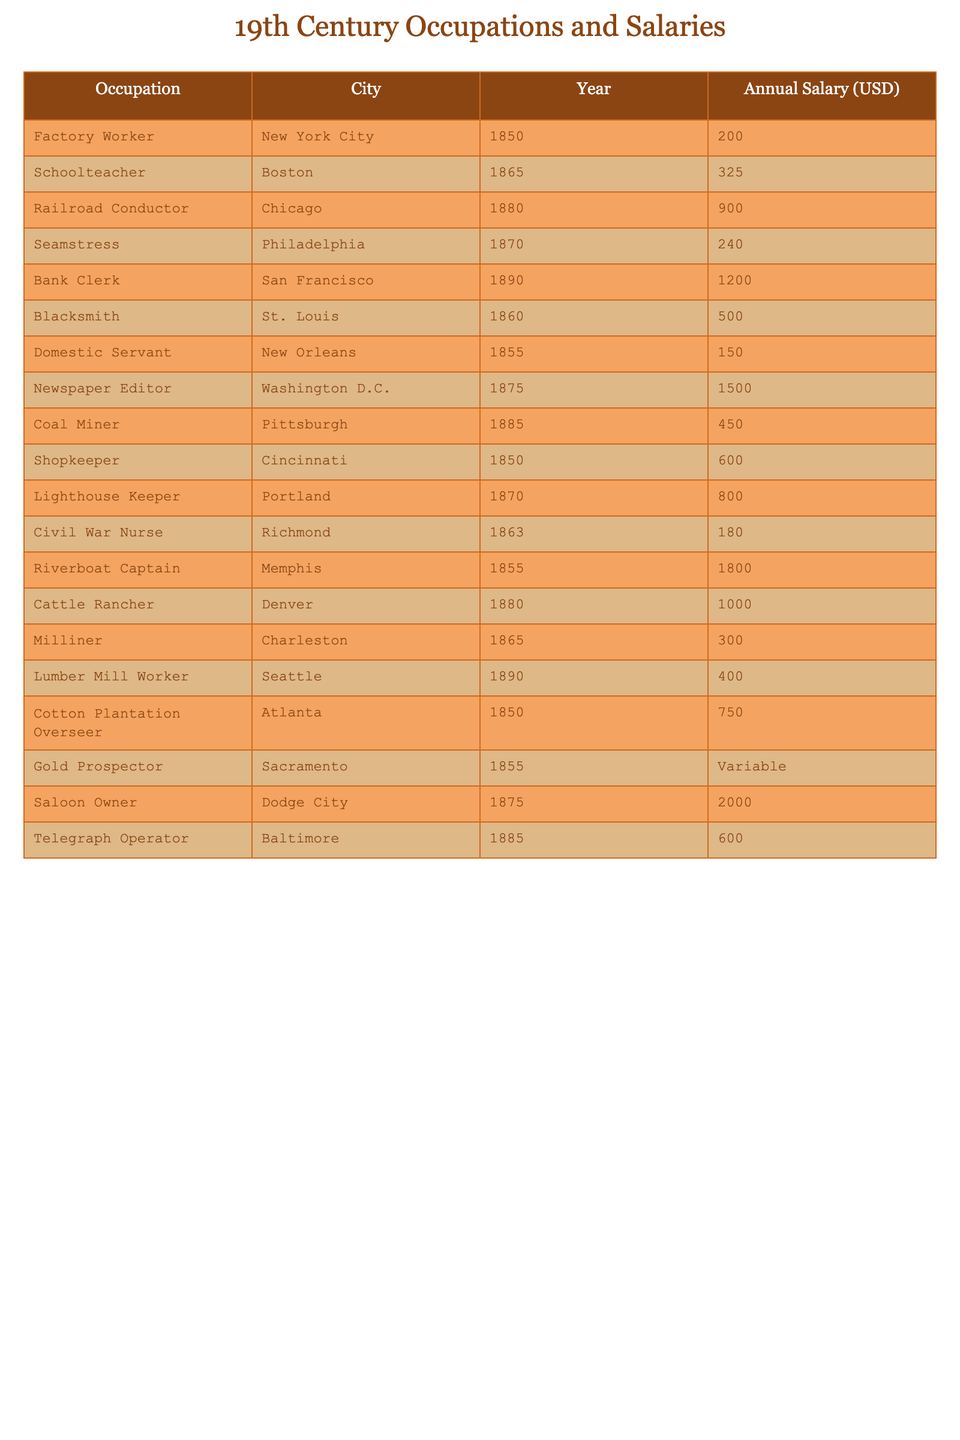What occupation had the highest average annual salary in 19th century U.S. cities? By scanning the "Annual Salary (USD)" column, I find that the "Saloon Owner" in Dodge City had the highest salary listed at 2000 USD.
Answer: Saloon Owner Which city had the lowest average annual salary among the listed occupations? Reviewing the salaries, the "Domestic Servant" in New Orleans had the lowest salary listed at 150 USD.
Answer: New Orleans How much more did the Newspaper Editor in Washington D.C. earn compared to the Domestic Servant in New Orleans? The Newspaper Editor earned 1500 USD, while the Domestic Servant earned 150 USD. Thus, the difference is 1500 - 150 = 1350 USD.
Answer: 1350 USD What is the average annual salary of a Factory Worker in New York City and a Shopkeeper in Cincinnati? The Factory Worker earned 200 USD and the Shopkeeper earned 600 USD. Adding them gives 200 + 600 = 800 USD. The average is 800 USD / 2 = 400 USD.
Answer: 400 USD Is the average salary of the occupations from the cities in the northern U.S. higher than that in the southern U.S.? The average salary for northern cities (New York City, Boston, Chicago, Philadelphia, San Francisco, St. Louis, and Washington D.C.) is calculated as (200 + 325 + 900 + 240 + 1200 + 500 + 1500) / 7 = 523. Hence, for southern cities (New Orleans, Richmond, Memphis, Atlanta, and Charleston) is (150 + 180 + 1800 + 750 + 300) / 5 = 435. Since 523 > 435, the northern average is indeed higher.
Answer: Yes Which occupation has a variable salary, and what does that imply about the income of individuals in that role? The "Gold Prospector" in Sacramento has a variable salary, which means that the income is not fixed and can fluctuate greatly depending on success in finding gold, unlike the other listed occupations with fixed salaries.
Answer: Gold Prospector How many occupations listed have an average salary above 800 USD? Scanning through the table, the occupations with salaries above 800 USD are: "Newspaper Editor" (1500), "Riverboat Captain" (1800), and "Saloon Owner" (2000), totaling three occupations.
Answer: 3 What is the combined annual salary of a Railroad Conductor and a Cattle Rancher? The Railroad Conductor earned 900 USD, and the Cattle Rancher earned 1000 USD. Adding these two gives 900 + 1000 = 1900 USD.
Answer: 1900 USD Did any occupation in 19th century U.S. cities earn exactly 400 USD? Reviewing the salary data, there are no entries that list exactly 400 USD, confirming that no occupation earned that specific amount during this time.
Answer: No Which city had more than one occupation listed, and what were those occupations? Chicago had two occupations listed: "Railroad Conductor" and "Riverboat Captain." Therefore, Chicago had multiple entries for different roles.
Answer: Chicago: Railroad Conductor, Riverboat Captain 